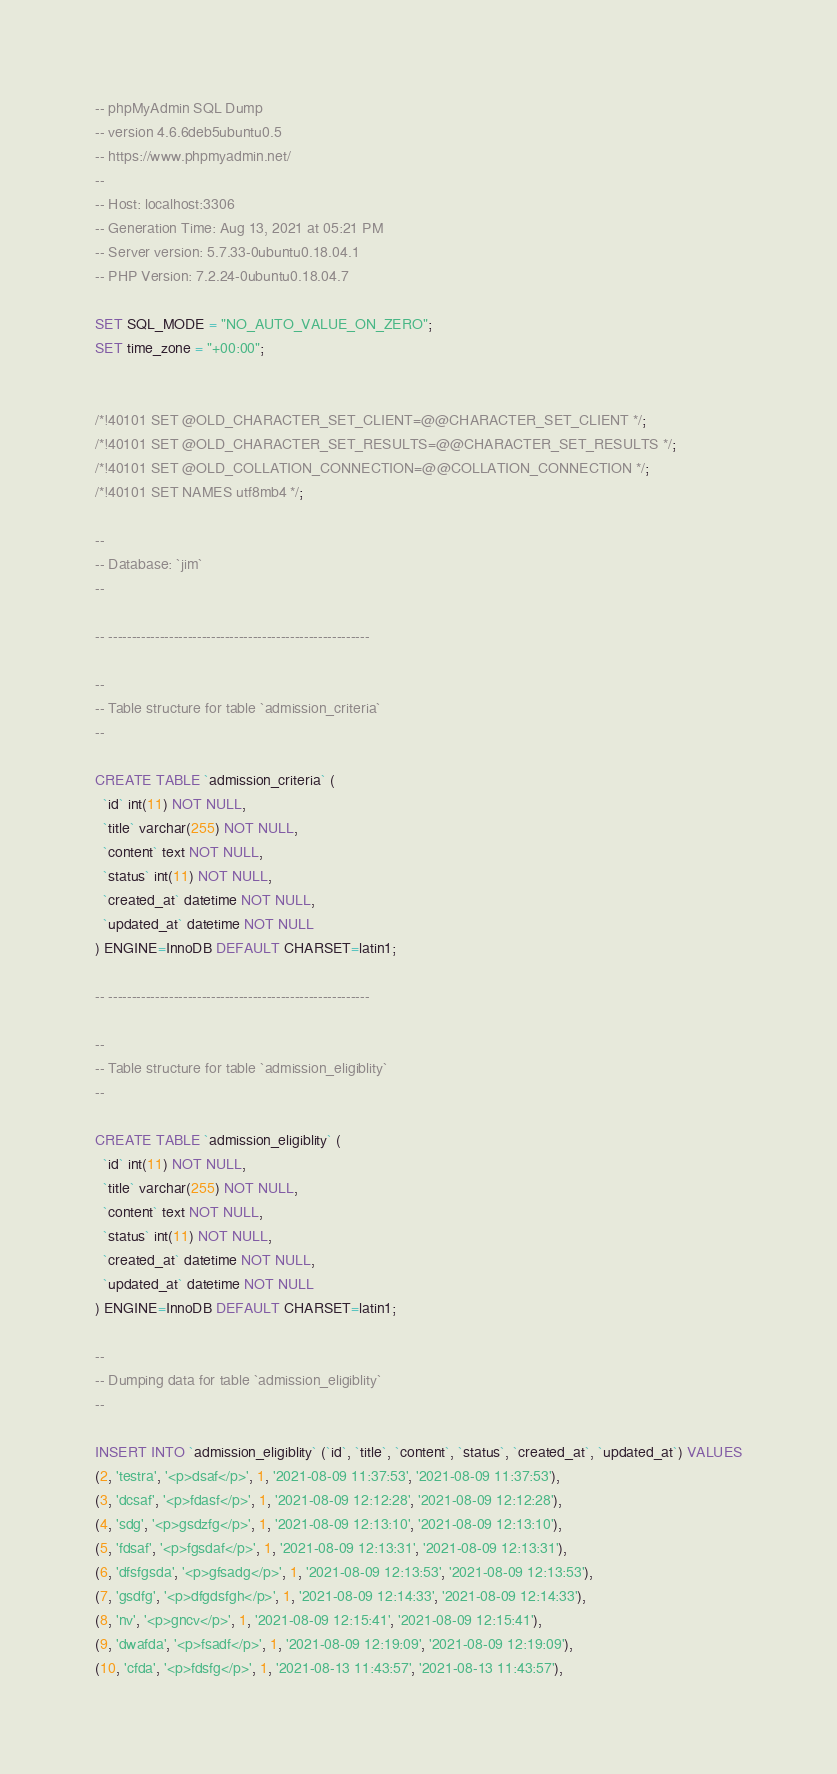<code> <loc_0><loc_0><loc_500><loc_500><_SQL_>-- phpMyAdmin SQL Dump
-- version 4.6.6deb5ubuntu0.5
-- https://www.phpmyadmin.net/
--
-- Host: localhost:3306
-- Generation Time: Aug 13, 2021 at 05:21 PM
-- Server version: 5.7.33-0ubuntu0.18.04.1
-- PHP Version: 7.2.24-0ubuntu0.18.04.7

SET SQL_MODE = "NO_AUTO_VALUE_ON_ZERO";
SET time_zone = "+00:00";


/*!40101 SET @OLD_CHARACTER_SET_CLIENT=@@CHARACTER_SET_CLIENT */;
/*!40101 SET @OLD_CHARACTER_SET_RESULTS=@@CHARACTER_SET_RESULTS */;
/*!40101 SET @OLD_COLLATION_CONNECTION=@@COLLATION_CONNECTION */;
/*!40101 SET NAMES utf8mb4 */;

--
-- Database: `jim`
--

-- --------------------------------------------------------

--
-- Table structure for table `admission_criteria`
--

CREATE TABLE `admission_criteria` (
  `id` int(11) NOT NULL,
  `title` varchar(255) NOT NULL,
  `content` text NOT NULL,
  `status` int(11) NOT NULL,
  `created_at` datetime NOT NULL,
  `updated_at` datetime NOT NULL
) ENGINE=InnoDB DEFAULT CHARSET=latin1;

-- --------------------------------------------------------

--
-- Table structure for table `admission_eligiblity`
--

CREATE TABLE `admission_eligiblity` (
  `id` int(11) NOT NULL,
  `title` varchar(255) NOT NULL,
  `content` text NOT NULL,
  `status` int(11) NOT NULL,
  `created_at` datetime NOT NULL,
  `updated_at` datetime NOT NULL
) ENGINE=InnoDB DEFAULT CHARSET=latin1;

--
-- Dumping data for table `admission_eligiblity`
--

INSERT INTO `admission_eligiblity` (`id`, `title`, `content`, `status`, `created_at`, `updated_at`) VALUES
(2, 'testra', '<p>dsaf</p>', 1, '2021-08-09 11:37:53', '2021-08-09 11:37:53'),
(3, 'dcsaf', '<p>fdasf</p>', 1, '2021-08-09 12:12:28', '2021-08-09 12:12:28'),
(4, 'sdg', '<p>gsdzfg</p>', 1, '2021-08-09 12:13:10', '2021-08-09 12:13:10'),
(5, 'fdsaf', '<p>fgsdaf</p>', 1, '2021-08-09 12:13:31', '2021-08-09 12:13:31'),
(6, 'dfsfgsda', '<p>gfsadg</p>', 1, '2021-08-09 12:13:53', '2021-08-09 12:13:53'),
(7, 'gsdfg', '<p>dfgdsfgh</p>', 1, '2021-08-09 12:14:33', '2021-08-09 12:14:33'),
(8, 'nv', '<p>gncv</p>', 1, '2021-08-09 12:15:41', '2021-08-09 12:15:41'),
(9, 'dwafda', '<p>fsadf</p>', 1, '2021-08-09 12:19:09', '2021-08-09 12:19:09'),
(10, 'cfda', '<p>fdsfg</p>', 1, '2021-08-13 11:43:57', '2021-08-13 11:43:57'),</code> 